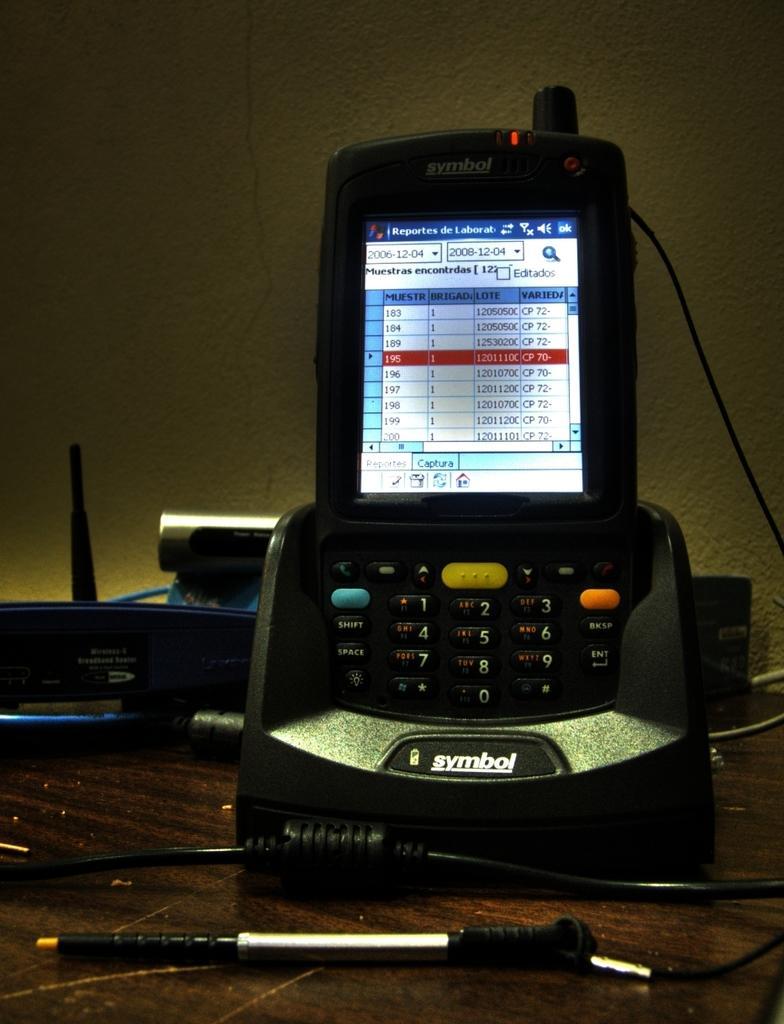Could you give a brief overview of what you see in this image? In the image we can see electronic devices, cable wire, wooden surface and the wall. 